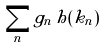Convert formula to latex. <formula><loc_0><loc_0><loc_500><loc_500>\sum _ { n } g _ { n } \, h ( k _ { n } )</formula> 